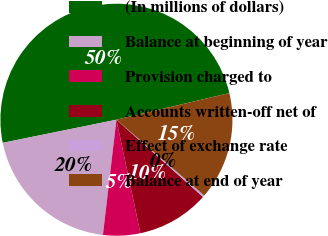<chart> <loc_0><loc_0><loc_500><loc_500><pie_chart><fcel>(In millions of dollars)<fcel>Balance at beginning of year<fcel>Provision charged to<fcel>Accounts written-off net of<fcel>Effect of exchange rate<fcel>Balance at end of year<nl><fcel>49.51%<fcel>19.95%<fcel>5.17%<fcel>10.1%<fcel>0.25%<fcel>15.02%<nl></chart> 